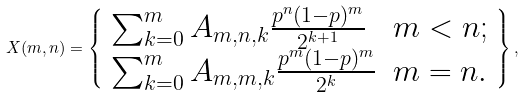Convert formula to latex. <formula><loc_0><loc_0><loc_500><loc_500>X ( m , n ) = \left \{ \begin{array} { l l } \sum _ { k = 0 } ^ { m } A _ { m , n , k } \frac { p ^ { n } ( 1 - p ) ^ { m } } { 2 ^ { k + 1 } } & m < n ; \\ \sum _ { k = 0 } ^ { m } A _ { m , m , k } \frac { p ^ { m } ( 1 - p ) ^ { m } } { 2 ^ { k } } & m = n . \end{array} \right \} ,</formula> 